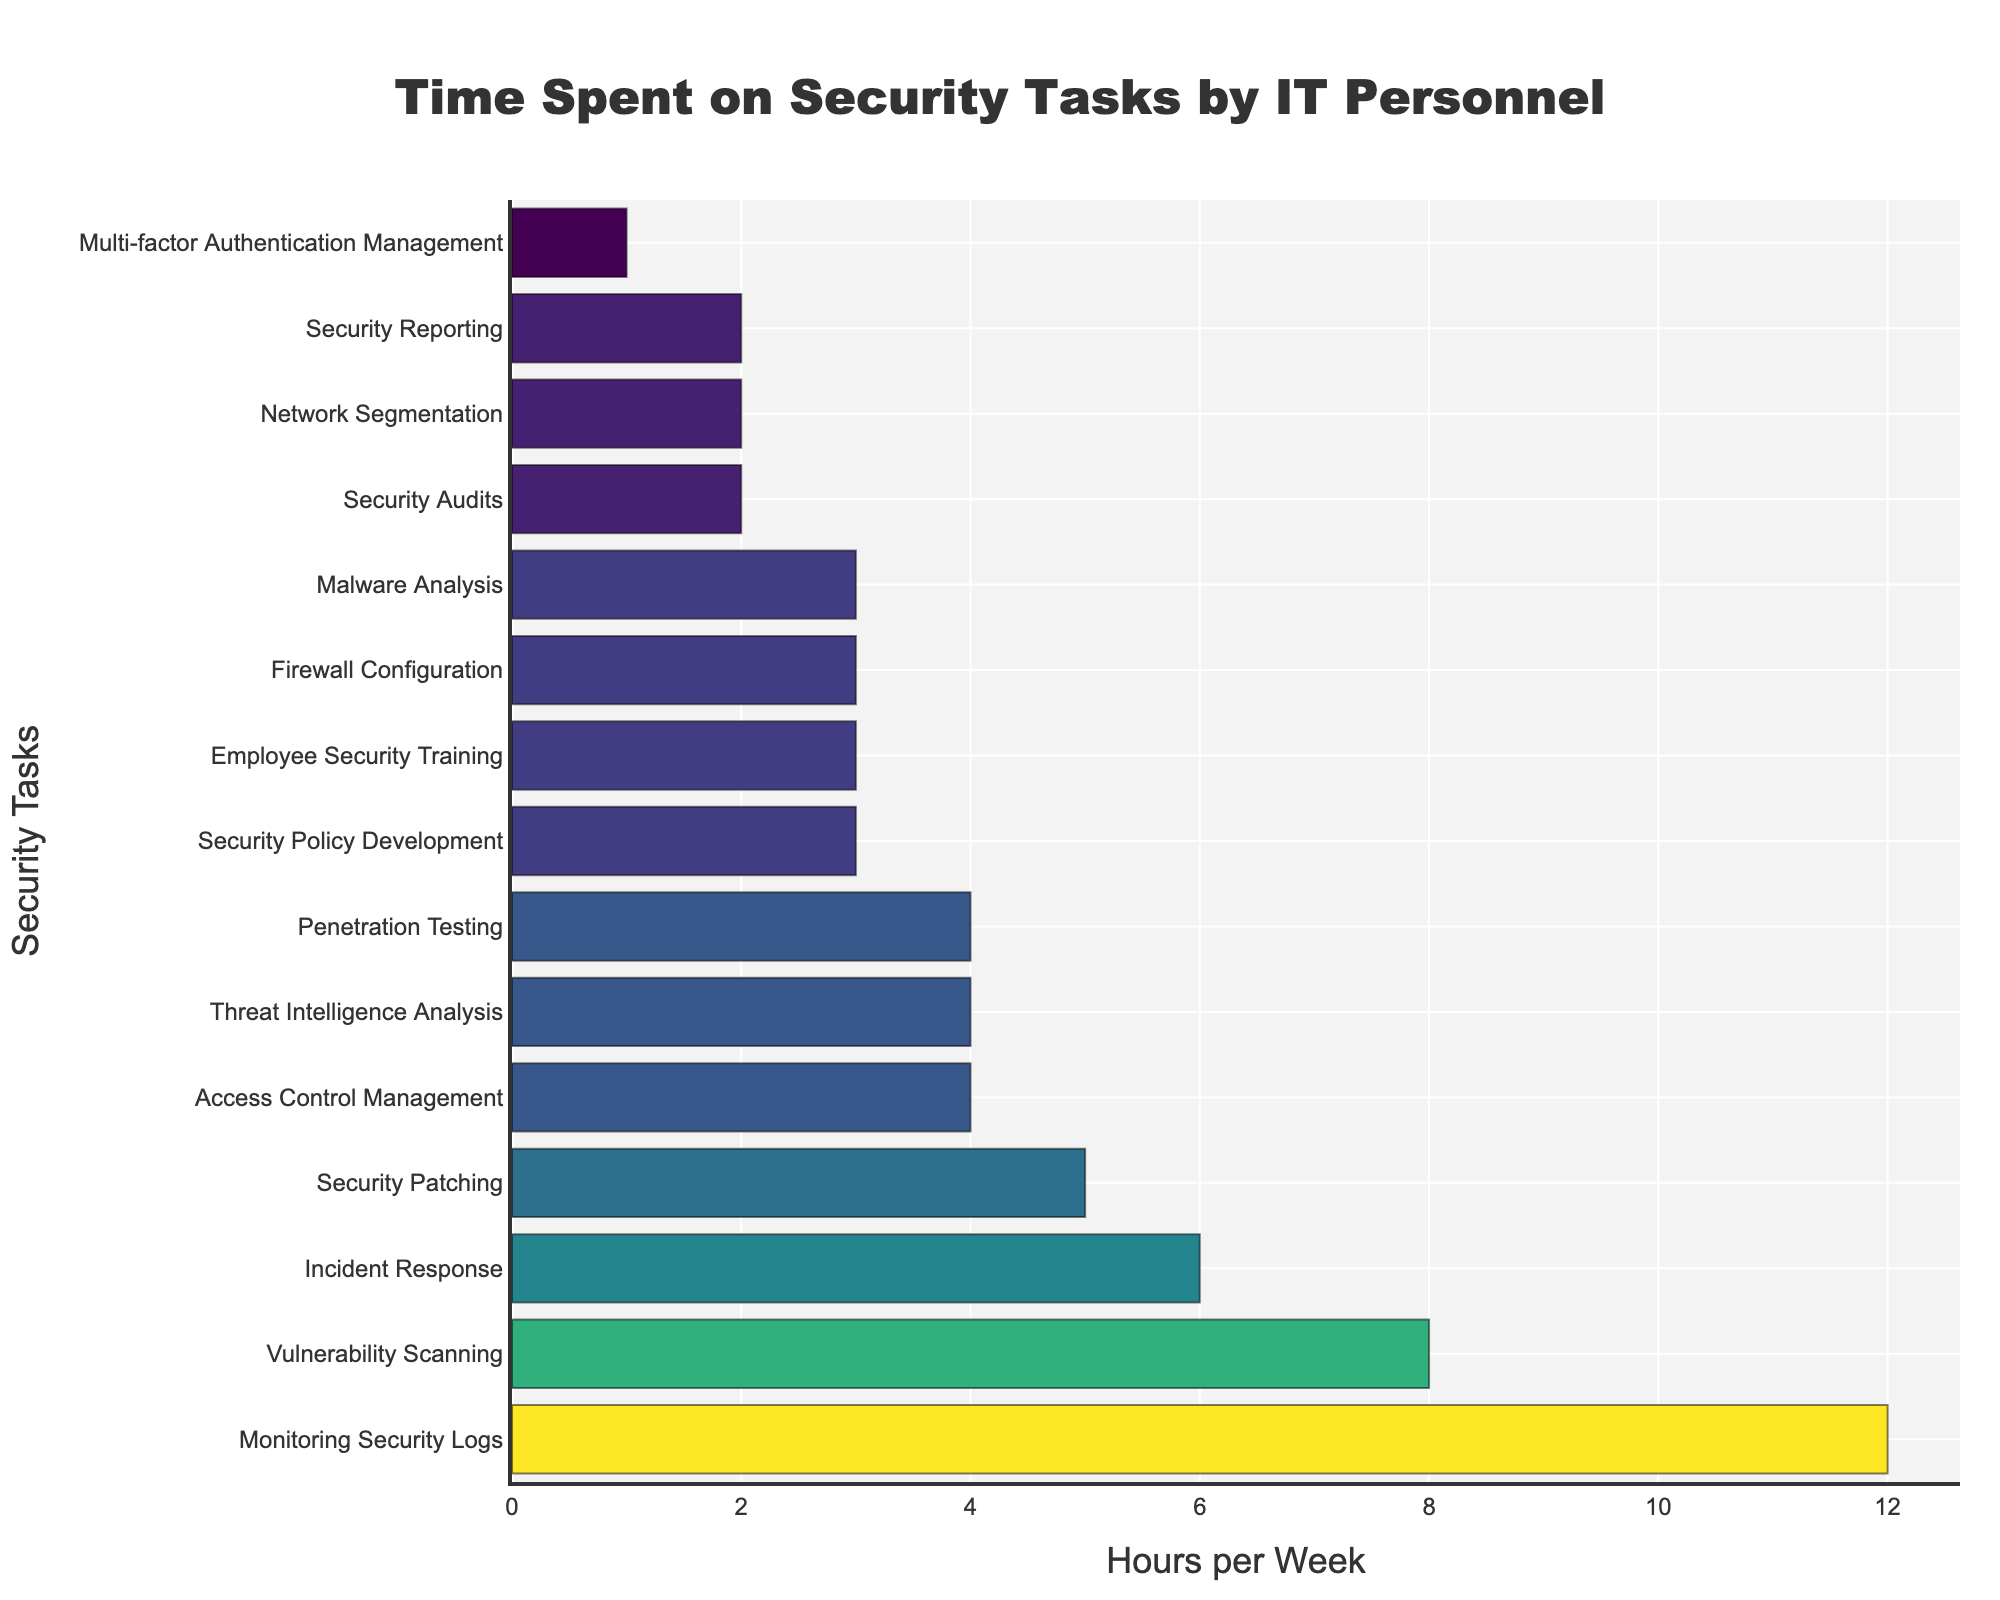What's the task with the highest time spent per week? The task with the longest bar represents the highest time spent, which is at the top of the sorted list. In this case, it's "Monitoring Security Logs".
Answer: Monitoring Security Logs Which task takes the least amount of time each week? The task with the shortest bar or is listed at the bottom of the ordered list, is "Multi-factor Authentication Management".
Answer: Multi-factor Authentication Management What is the total time spent on "Vulnerability Scanning" and "Penetration Testing"? The time spent on "Vulnerability Scanning" is 8 hours, and the time on "Penetration Testing" is 4 hours. Adding these together gives us 12 hours.
Answer: 12 hours How much more time is spent on "Incident Response" compared to "Employee Security Training"? "Incident Response" takes 6 hours, while "Employee Security Training" takes 3 hours. The difference is 6 - 3 = 3 hours.
Answer: 3 hours What is the average time spent on the top three tasks? The hours for the top three tasks are 12 (Monitoring Security Logs), 8 (Vulnerability Scanning), and 6 (Incident Response). The average is calculated as (12 + 8 + 6) / 3 = 26 / 3 ≈ 8.67 hours.
Answer: 8.67 hours Which tasks take an equal amount of time per week, and how many hours are those? "Access Control Management", "Threat Intelligence Analysis", and "Penetration Testing" each take 4 hours per week.
Answer: 4 hours What is the combined total time spent on the least three time-consuming tasks? The hours are 2 (Security Audits), 2 (Network Segmentation), and 1 (Multi-factor Authentication Management). Adding these together gives 2 + 2 + 1 = 5 hours.
Answer: 5 hours Is more time spent on "Monitoring Security Logs" than on "Incident Response", "Security Patching", and "Access Control Management" combined? The time spent on "Monitoring Security Logs" is 12 hours. The combined time for "Incident Response" (6), "Security Patching" (5), and "Access Control Management" (4) is 6 + 5 + 4 = 15 hours. Therefore, 12 < 15. No, more time is spent on the latter tasks combined.
Answer: No How much time is spent on activities related specifically to security policies and training? The relevant tasks are "Employee Security Training" (3 hours) and "Security Policy Development" (3 hours). Together, they sum up to 3 + 3 = 6 hours.
Answer: 6 hours 